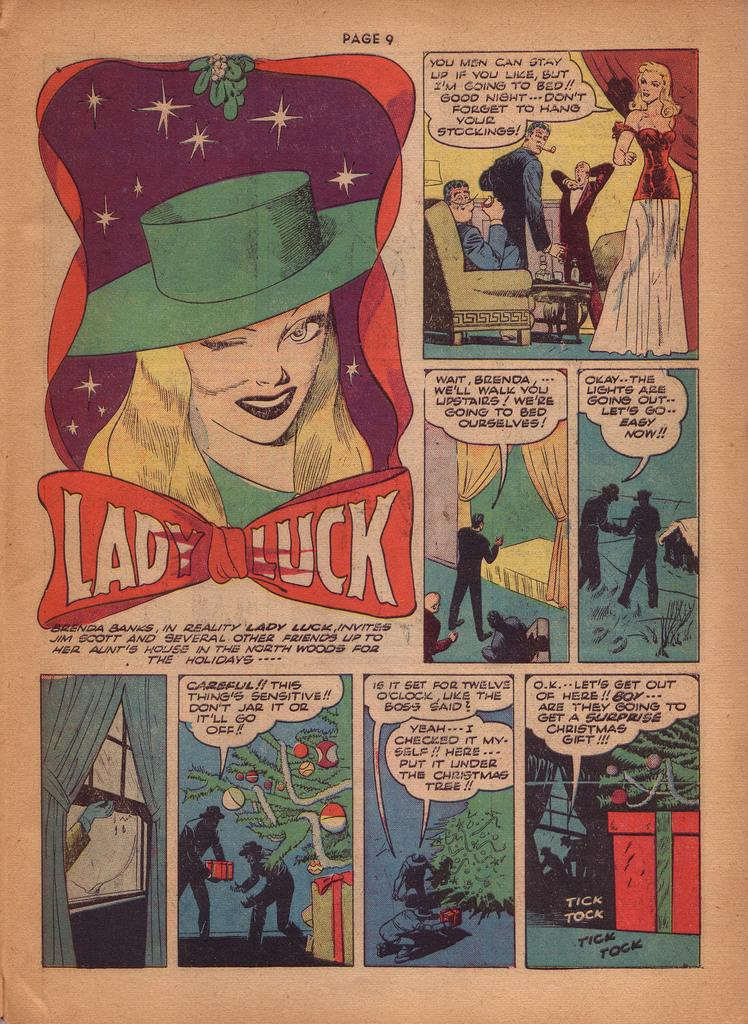Provide a one-sentence caption for the provided image. One of the panels of a slightly faded comic strip includes a woman and the words Lady Luck. 